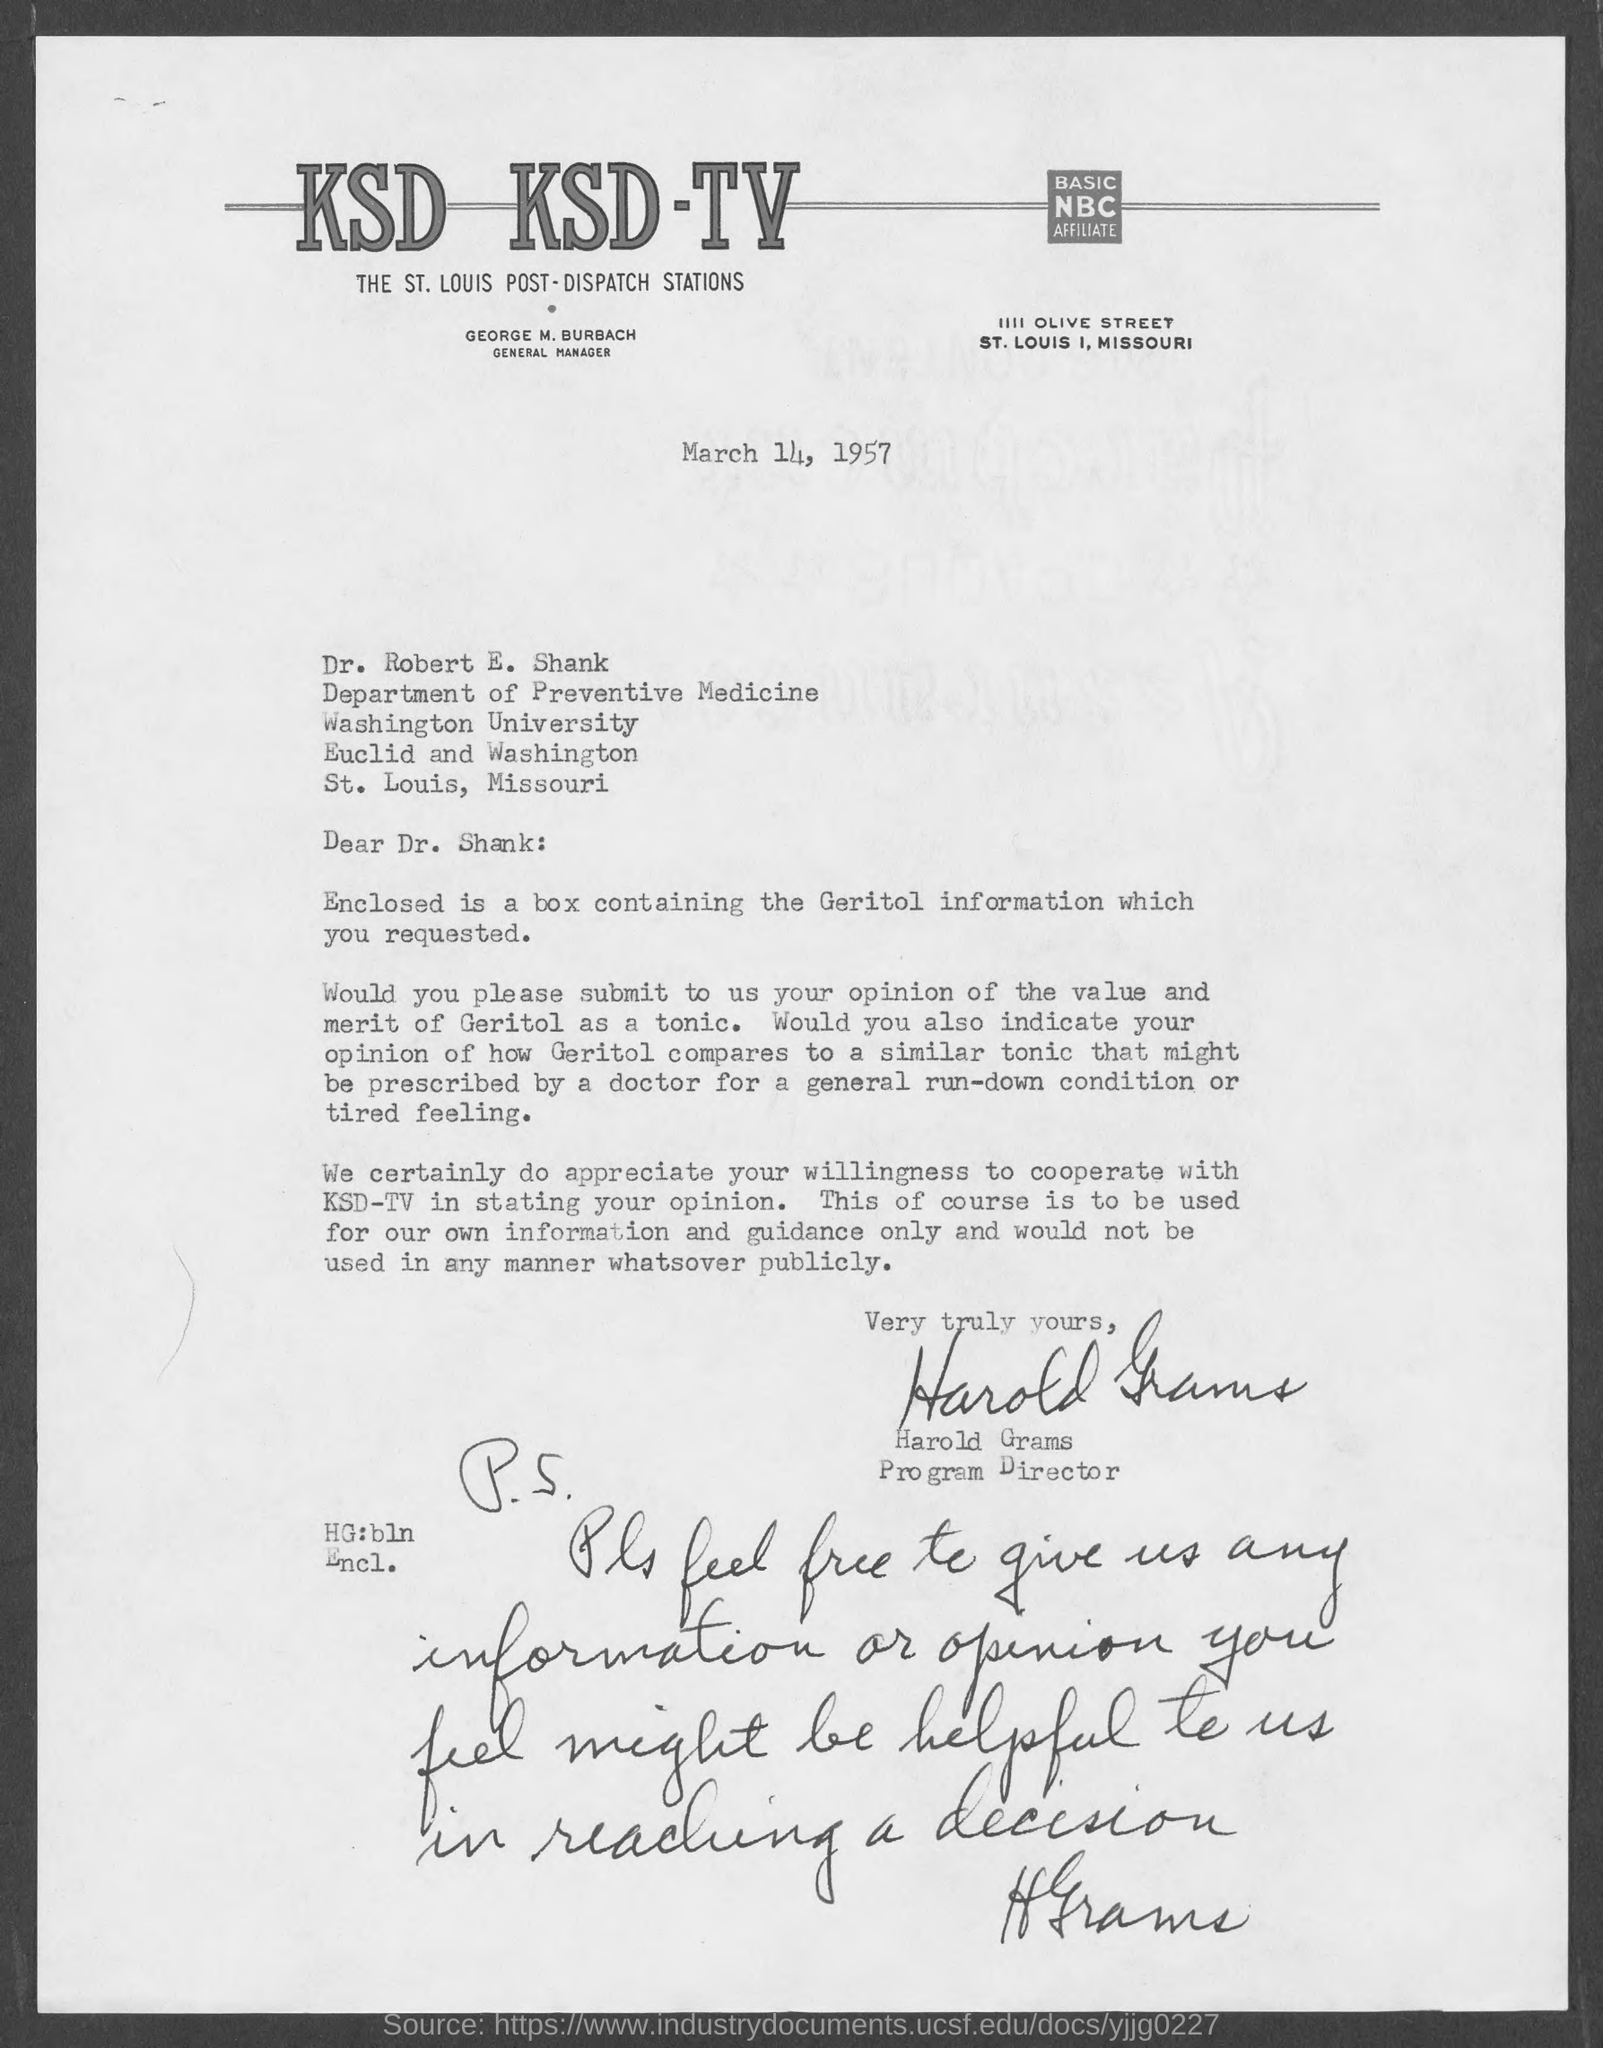Highlight a few significant elements in this photo. The letter is accompanied by a box containing information about Geritol. This letter is written to Dr. Robert E. Shank. The individual known as George M. Burbach is the General Manager of KSD-TV. Harold Grams is the Program Director. Dr. Robert E. Shank is a member of the Department of Preventive Medicine. 